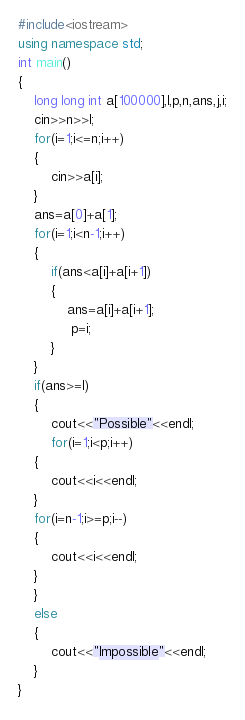Convert code to text. <code><loc_0><loc_0><loc_500><loc_500><_C++_>#include<iostream>
using namespace std;
int main()
{
    long long int a[100000],l,p,n,ans,j,i;
    cin>>n>>l;
    for(i=1;i<=n;i++)
    {
        cin>>a[i];
    }
    ans=a[0]+a[1];
    for(i=1;i<n-1;i++)
    {
        if(ans<a[i]+a[i+1])
        {
            ans=a[i]+a[i+1];
             p=i;
        }
    }
    if(ans>=l)
    {
        cout<<"Possible"<<endl;
        for(i=1;i<p;i++)
    {
        cout<<i<<endl;
    }
    for(i=n-1;i>=p;i--)
    {
        cout<<i<<endl;
    }
    }
    else
    {
        cout<<"Impossible"<<endl;
    }
}
</code> 